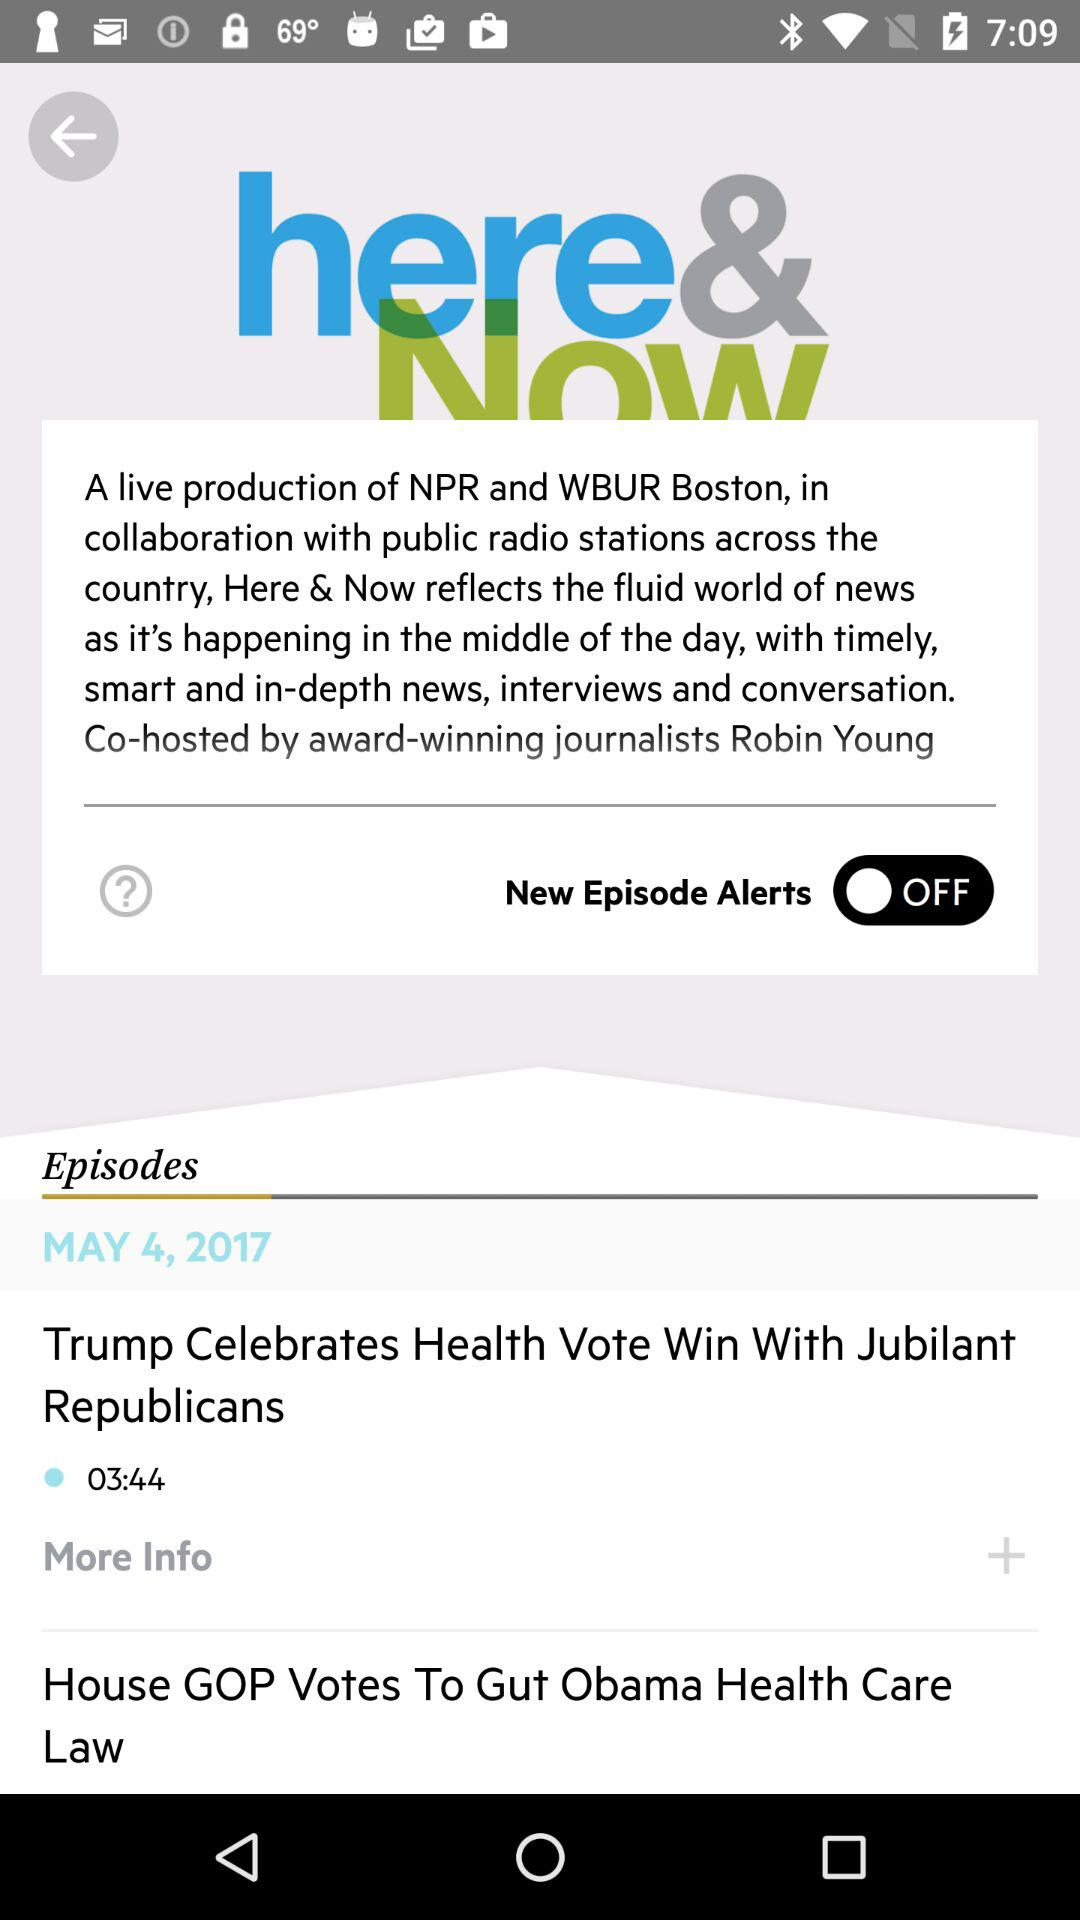What's the status of "New Episode Alerts"? The status is "off". 